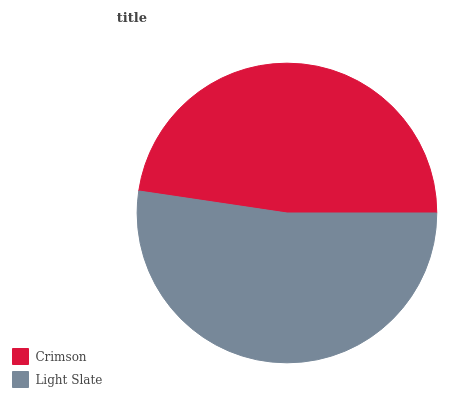Is Crimson the minimum?
Answer yes or no. Yes. Is Light Slate the maximum?
Answer yes or no. Yes. Is Light Slate the minimum?
Answer yes or no. No. Is Light Slate greater than Crimson?
Answer yes or no. Yes. Is Crimson less than Light Slate?
Answer yes or no. Yes. Is Crimson greater than Light Slate?
Answer yes or no. No. Is Light Slate less than Crimson?
Answer yes or no. No. Is Light Slate the high median?
Answer yes or no. Yes. Is Crimson the low median?
Answer yes or no. Yes. Is Crimson the high median?
Answer yes or no. No. Is Light Slate the low median?
Answer yes or no. No. 